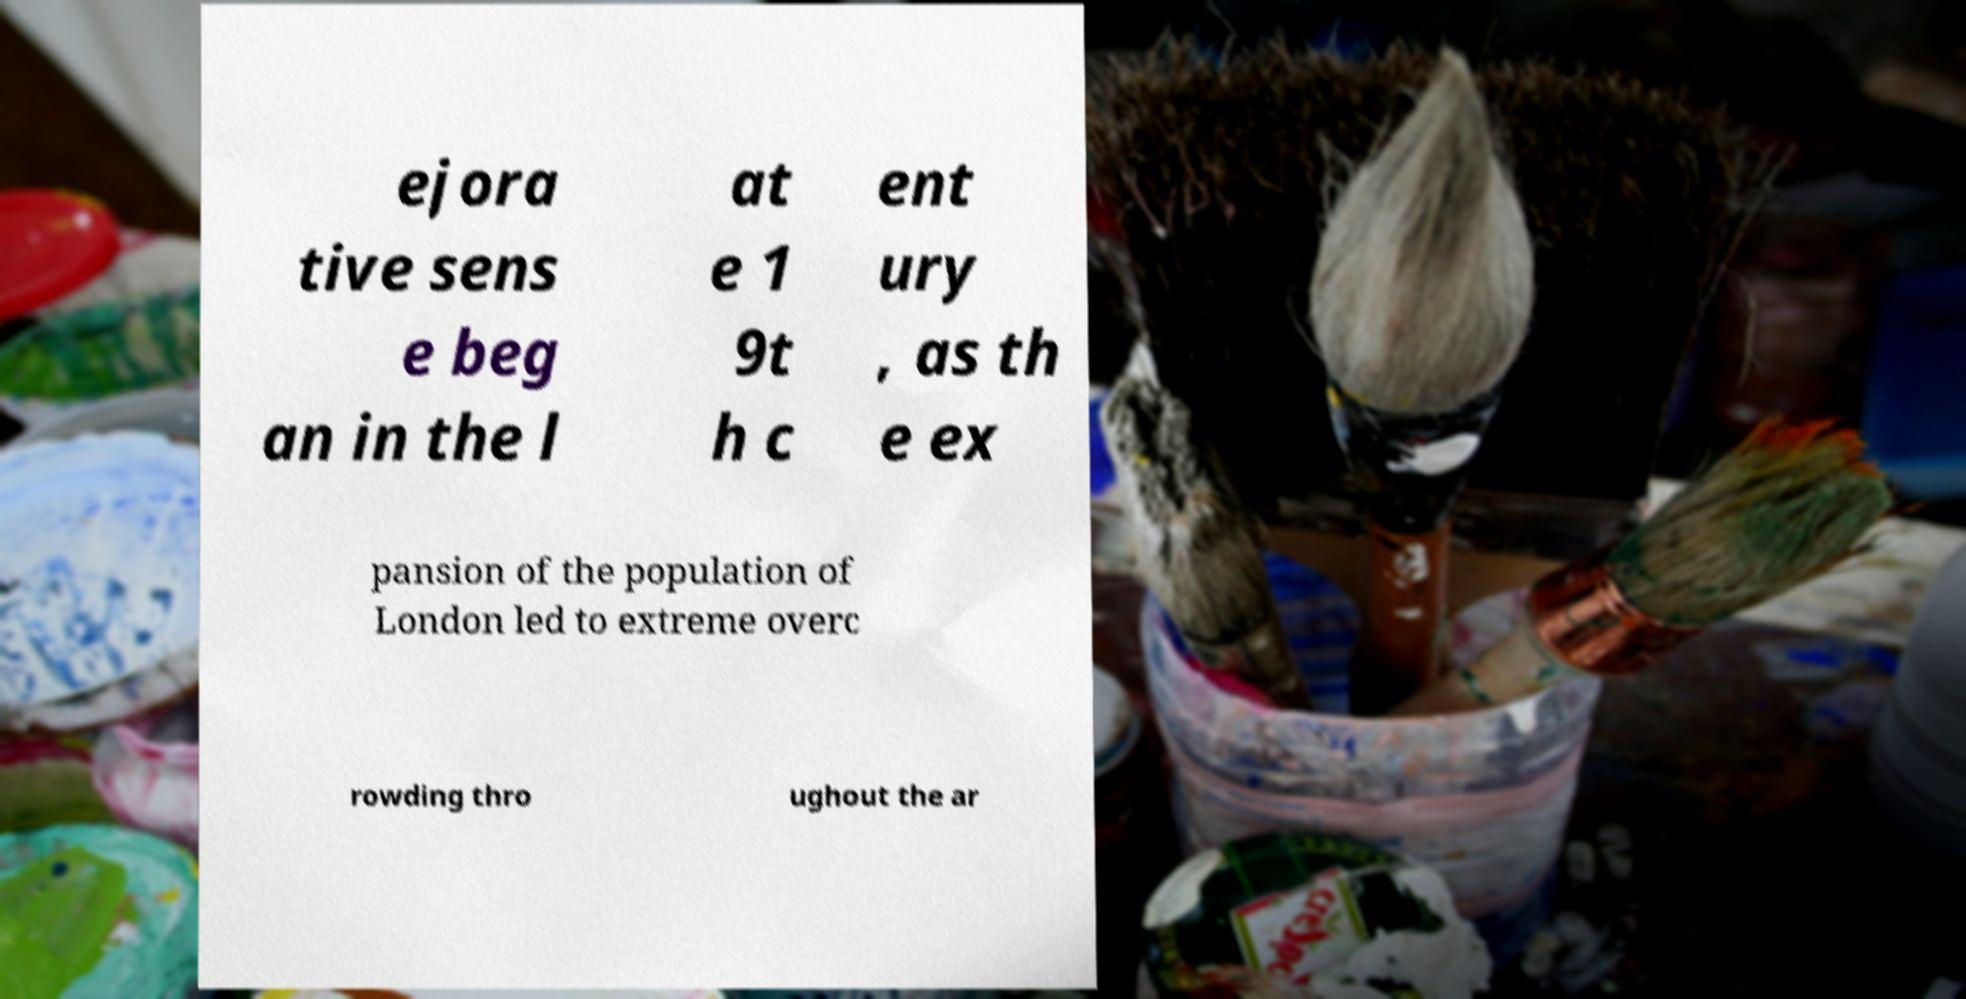I need the written content from this picture converted into text. Can you do that? ejora tive sens e beg an in the l at e 1 9t h c ent ury , as th e ex pansion of the population of London led to extreme overc rowding thro ughout the ar 